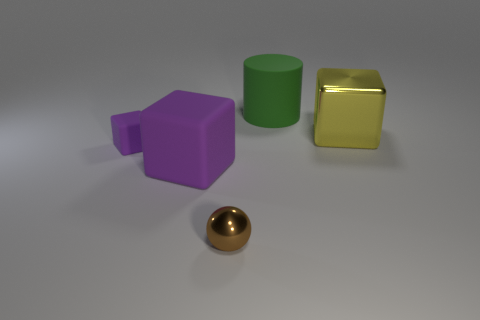Subtract all metallic cubes. How many cubes are left? 2 Add 2 green objects. How many objects exist? 7 Subtract all purple blocks. How many blocks are left? 1 Subtract all cyan balls. How many purple blocks are left? 2 Subtract 0 gray cylinders. How many objects are left? 5 Subtract all balls. How many objects are left? 4 Subtract 2 blocks. How many blocks are left? 1 Subtract all brown cubes. Subtract all gray spheres. How many cubes are left? 3 Subtract all big yellow cubes. Subtract all tiny purple objects. How many objects are left? 3 Add 5 big shiny things. How many big shiny things are left? 6 